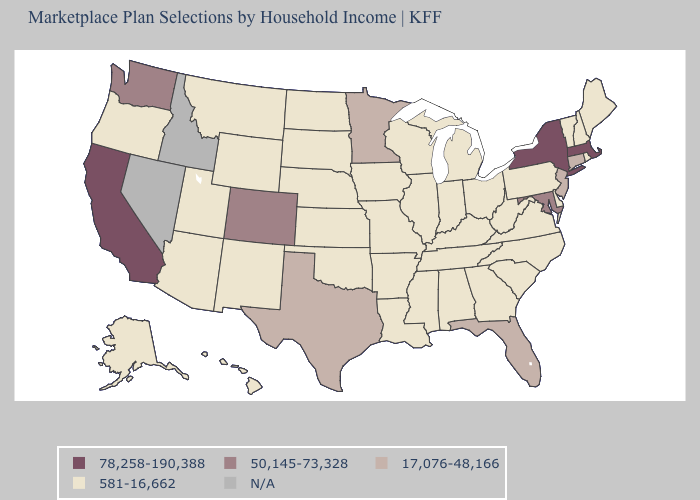Name the states that have a value in the range 50,145-73,328?
Keep it brief. Colorado, Maryland, Washington. What is the value of South Carolina?
Give a very brief answer. 581-16,662. Name the states that have a value in the range 581-16,662?
Short answer required. Alabama, Alaska, Arizona, Arkansas, Delaware, Georgia, Hawaii, Illinois, Indiana, Iowa, Kansas, Kentucky, Louisiana, Maine, Michigan, Mississippi, Missouri, Montana, Nebraska, New Hampshire, New Mexico, North Carolina, North Dakota, Ohio, Oklahoma, Oregon, Pennsylvania, Rhode Island, South Carolina, South Dakota, Tennessee, Utah, Vermont, Virginia, West Virginia, Wisconsin, Wyoming. What is the lowest value in the Northeast?
Write a very short answer. 581-16,662. What is the highest value in the South ?
Be succinct. 50,145-73,328. Does the first symbol in the legend represent the smallest category?
Short answer required. No. Is the legend a continuous bar?
Concise answer only. No. What is the lowest value in the MidWest?
Be succinct. 581-16,662. Among the states that border Nebraska , does South Dakota have the highest value?
Concise answer only. No. Name the states that have a value in the range N/A?
Concise answer only. Idaho, Nevada. Which states hav the highest value in the Northeast?
Keep it brief. Massachusetts, New York. Does the map have missing data?
Concise answer only. Yes. What is the value of Rhode Island?
Keep it brief. 581-16,662. 